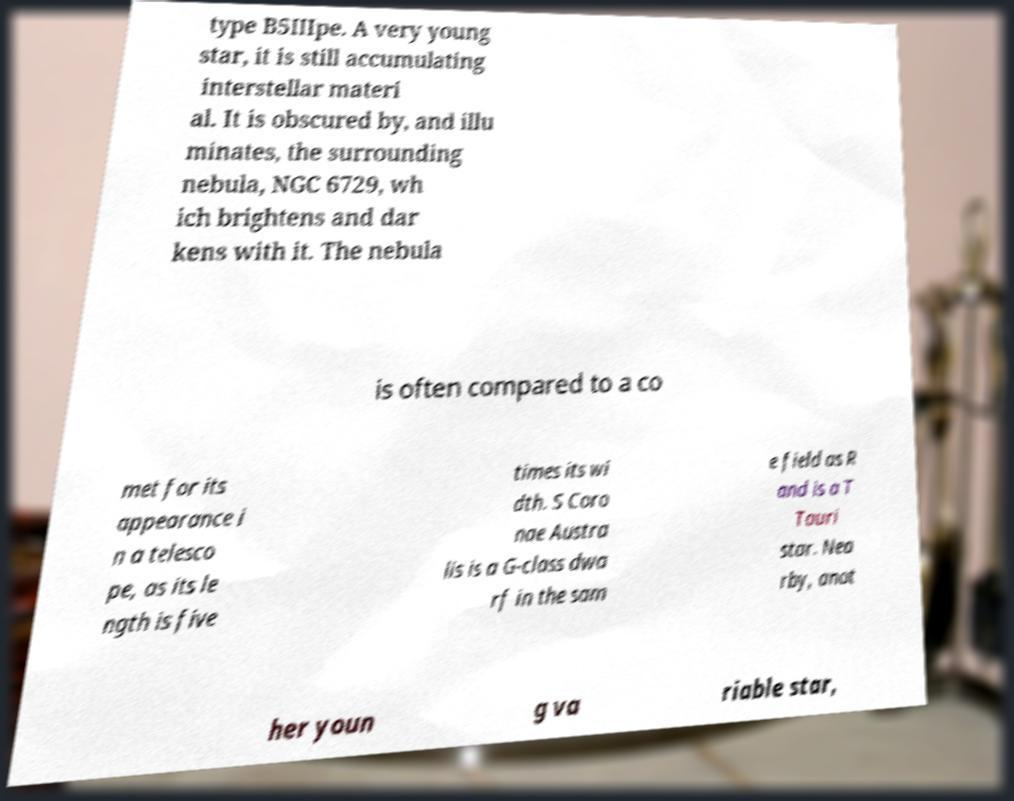I need the written content from this picture converted into text. Can you do that? type B5IIIpe. A very young star, it is still accumulating interstellar materi al. It is obscured by, and illu minates, the surrounding nebula, NGC 6729, wh ich brightens and dar kens with it. The nebula is often compared to a co met for its appearance i n a telesco pe, as its le ngth is five times its wi dth. S Coro nae Austra lis is a G-class dwa rf in the sam e field as R and is a T Tauri star. Nea rby, anot her youn g va riable star, 